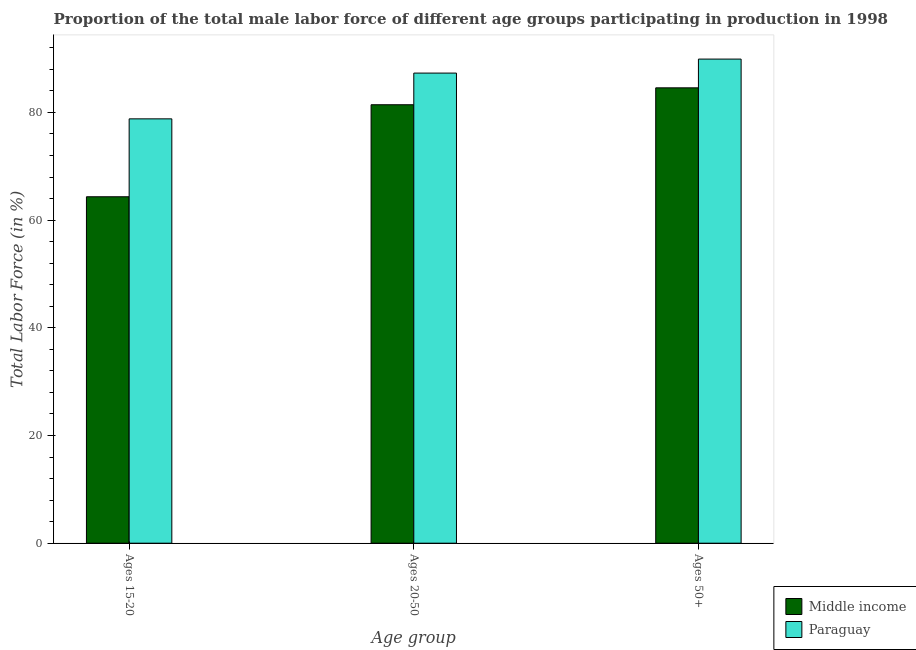Are the number of bars per tick equal to the number of legend labels?
Your answer should be very brief. Yes. What is the label of the 1st group of bars from the left?
Offer a terse response. Ages 15-20. What is the percentage of male labor force above age 50 in Middle income?
Your answer should be compact. 84.56. Across all countries, what is the maximum percentage of male labor force within the age group 20-50?
Your answer should be very brief. 87.3. Across all countries, what is the minimum percentage of male labor force within the age group 20-50?
Provide a short and direct response. 81.42. In which country was the percentage of male labor force within the age group 20-50 maximum?
Offer a terse response. Paraguay. In which country was the percentage of male labor force within the age group 15-20 minimum?
Offer a very short reply. Middle income. What is the total percentage of male labor force within the age group 20-50 in the graph?
Ensure brevity in your answer.  168.72. What is the difference between the percentage of male labor force above age 50 in Paraguay and that in Middle income?
Provide a short and direct response. 5.34. What is the difference between the percentage of male labor force within the age group 15-20 in Paraguay and the percentage of male labor force above age 50 in Middle income?
Your answer should be compact. -5.76. What is the average percentage of male labor force above age 50 per country?
Provide a succinct answer. 87.23. What is the difference between the percentage of male labor force within the age group 20-50 and percentage of male labor force within the age group 15-20 in Middle income?
Your answer should be very brief. 17.09. What is the ratio of the percentage of male labor force within the age group 20-50 in Paraguay to that in Middle income?
Provide a succinct answer. 1.07. Is the difference between the percentage of male labor force above age 50 in Paraguay and Middle income greater than the difference between the percentage of male labor force within the age group 20-50 in Paraguay and Middle income?
Give a very brief answer. No. What is the difference between the highest and the second highest percentage of male labor force within the age group 20-50?
Ensure brevity in your answer.  5.88. What is the difference between the highest and the lowest percentage of male labor force within the age group 15-20?
Offer a very short reply. 14.47. In how many countries, is the percentage of male labor force within the age group 20-50 greater than the average percentage of male labor force within the age group 20-50 taken over all countries?
Provide a short and direct response. 1. Is the sum of the percentage of male labor force within the age group 15-20 in Paraguay and Middle income greater than the maximum percentage of male labor force within the age group 20-50 across all countries?
Provide a succinct answer. Yes. What does the 2nd bar from the left in Ages 15-20 represents?
Keep it short and to the point. Paraguay. What does the 2nd bar from the right in Ages 20-50 represents?
Give a very brief answer. Middle income. How many bars are there?
Offer a terse response. 6. Are all the bars in the graph horizontal?
Your answer should be very brief. No. What is the difference between two consecutive major ticks on the Y-axis?
Offer a terse response. 20. Does the graph contain any zero values?
Offer a terse response. No. Where does the legend appear in the graph?
Keep it short and to the point. Bottom right. How are the legend labels stacked?
Your response must be concise. Vertical. What is the title of the graph?
Provide a short and direct response. Proportion of the total male labor force of different age groups participating in production in 1998. Does "Yemen, Rep." appear as one of the legend labels in the graph?
Provide a succinct answer. No. What is the label or title of the X-axis?
Your answer should be compact. Age group. What is the label or title of the Y-axis?
Provide a short and direct response. Total Labor Force (in %). What is the Total Labor Force (in %) of Middle income in Ages 15-20?
Provide a short and direct response. 64.33. What is the Total Labor Force (in %) of Paraguay in Ages 15-20?
Make the answer very short. 78.8. What is the Total Labor Force (in %) in Middle income in Ages 20-50?
Provide a short and direct response. 81.42. What is the Total Labor Force (in %) of Paraguay in Ages 20-50?
Provide a succinct answer. 87.3. What is the Total Labor Force (in %) of Middle income in Ages 50+?
Keep it short and to the point. 84.56. What is the Total Labor Force (in %) of Paraguay in Ages 50+?
Keep it short and to the point. 89.9. Across all Age group, what is the maximum Total Labor Force (in %) in Middle income?
Offer a terse response. 84.56. Across all Age group, what is the maximum Total Labor Force (in %) in Paraguay?
Your response must be concise. 89.9. Across all Age group, what is the minimum Total Labor Force (in %) in Middle income?
Provide a short and direct response. 64.33. Across all Age group, what is the minimum Total Labor Force (in %) in Paraguay?
Offer a very short reply. 78.8. What is the total Total Labor Force (in %) of Middle income in the graph?
Keep it short and to the point. 230.31. What is the total Total Labor Force (in %) of Paraguay in the graph?
Provide a succinct answer. 256. What is the difference between the Total Labor Force (in %) of Middle income in Ages 15-20 and that in Ages 20-50?
Your answer should be very brief. -17.09. What is the difference between the Total Labor Force (in %) of Paraguay in Ages 15-20 and that in Ages 20-50?
Keep it short and to the point. -8.5. What is the difference between the Total Labor Force (in %) in Middle income in Ages 15-20 and that in Ages 50+?
Provide a succinct answer. -20.23. What is the difference between the Total Labor Force (in %) in Middle income in Ages 20-50 and that in Ages 50+?
Offer a very short reply. -3.14. What is the difference between the Total Labor Force (in %) in Paraguay in Ages 20-50 and that in Ages 50+?
Make the answer very short. -2.6. What is the difference between the Total Labor Force (in %) of Middle income in Ages 15-20 and the Total Labor Force (in %) of Paraguay in Ages 20-50?
Your answer should be compact. -22.97. What is the difference between the Total Labor Force (in %) in Middle income in Ages 15-20 and the Total Labor Force (in %) in Paraguay in Ages 50+?
Provide a succinct answer. -25.57. What is the difference between the Total Labor Force (in %) of Middle income in Ages 20-50 and the Total Labor Force (in %) of Paraguay in Ages 50+?
Offer a very short reply. -8.48. What is the average Total Labor Force (in %) of Middle income per Age group?
Provide a short and direct response. 76.77. What is the average Total Labor Force (in %) of Paraguay per Age group?
Ensure brevity in your answer.  85.33. What is the difference between the Total Labor Force (in %) in Middle income and Total Labor Force (in %) in Paraguay in Ages 15-20?
Give a very brief answer. -14.47. What is the difference between the Total Labor Force (in %) of Middle income and Total Labor Force (in %) of Paraguay in Ages 20-50?
Your response must be concise. -5.88. What is the difference between the Total Labor Force (in %) in Middle income and Total Labor Force (in %) in Paraguay in Ages 50+?
Your answer should be very brief. -5.34. What is the ratio of the Total Labor Force (in %) of Middle income in Ages 15-20 to that in Ages 20-50?
Offer a terse response. 0.79. What is the ratio of the Total Labor Force (in %) in Paraguay in Ages 15-20 to that in Ages 20-50?
Offer a very short reply. 0.9. What is the ratio of the Total Labor Force (in %) of Middle income in Ages 15-20 to that in Ages 50+?
Your response must be concise. 0.76. What is the ratio of the Total Labor Force (in %) of Paraguay in Ages 15-20 to that in Ages 50+?
Provide a short and direct response. 0.88. What is the ratio of the Total Labor Force (in %) in Middle income in Ages 20-50 to that in Ages 50+?
Give a very brief answer. 0.96. What is the ratio of the Total Labor Force (in %) of Paraguay in Ages 20-50 to that in Ages 50+?
Give a very brief answer. 0.97. What is the difference between the highest and the second highest Total Labor Force (in %) in Middle income?
Offer a very short reply. 3.14. What is the difference between the highest and the second highest Total Labor Force (in %) in Paraguay?
Offer a terse response. 2.6. What is the difference between the highest and the lowest Total Labor Force (in %) in Middle income?
Make the answer very short. 20.23. What is the difference between the highest and the lowest Total Labor Force (in %) of Paraguay?
Your response must be concise. 11.1. 